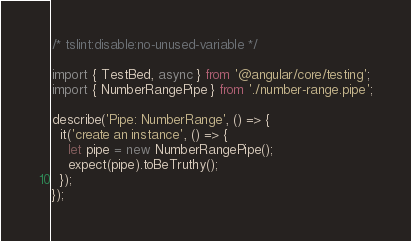<code> <loc_0><loc_0><loc_500><loc_500><_TypeScript_>/* tslint:disable:no-unused-variable */

import { TestBed, async } from '@angular/core/testing';
import { NumberRangePipe } from './number-range.pipe';

describe('Pipe: NumberRange', () => {
  it('create an instance', () => {
    let pipe = new NumberRangePipe();
    expect(pipe).toBeTruthy();
  });
});
</code> 